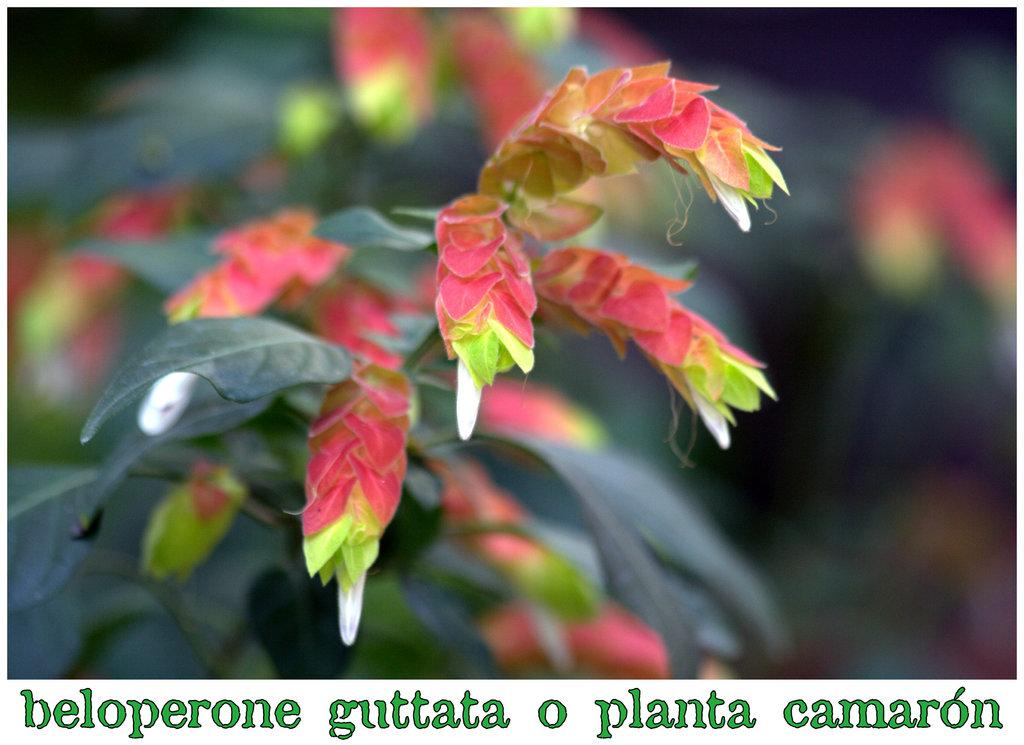What is the main subject in the middle of the image? There is a plant in the middle of the image. Can you describe the background of the image? The background of the image is blurry. Is there any text or information at the bottom of the image? Yes, there is something written at the bottom of the image. What type of cloud can be seen in the image? There is no cloud present in the image; it features a plant in the middle of the image with a blurry background. What grade is the farm in the image? There is no farm present in the image, and therefore no grade can be assigned. 